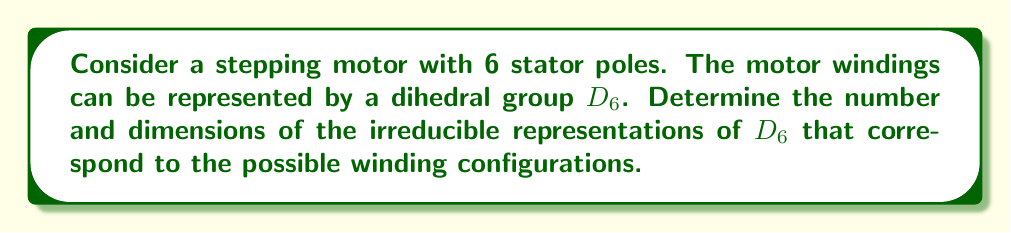Help me with this question. Let's approach this step-by-step:

1) The dihedral group $D_6$ has order 12, consisting of 6 rotations and 6 reflections.

2) For a dihedral group $D_n$, the number and dimensions of irreducible representations depend on whether $n$ is even or odd. In this case, $n = 6$, which is even.

3) For even $n$, $D_n$ has:
   - Four 1-dimensional irreducible representations
   - $(n-2)/2$ 2-dimensional irreducible representations

4) Let's calculate:
   - 1-dimensional representations: 4
   - 2-dimensional representations: $(6-2)/2 = 2$

5) To verify, we can use the sum of squares formula:
   $$ 4 \cdot 1^2 + 2 \cdot 2^2 = 4 + 8 = 12 $$
   This equals the order of $D_6$, confirming our calculation.

6) Interpreting for the motor:
   - The 1-dimensional representations correspond to symmetric winding configurations that are invariant under certain symmetry operations.
   - The 2-dimensional representations correspond to winding configurations that transform into each other under the symmetry operations of $D_6$.

7) In total, we have 6 irreducible representations (4 of dimension 1, and 2 of dimension 2).
Answer: 6 irreducible representations: 4 of dimension 1, 2 of dimension 2 